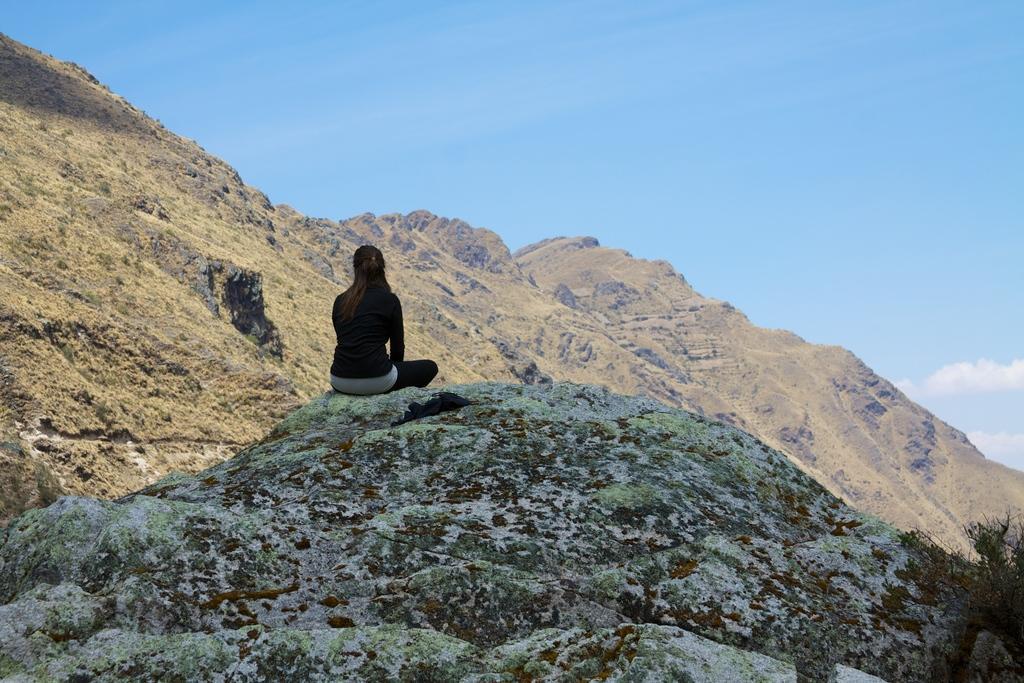How would you summarize this image in a sentence or two? In this picture we can see the beautiful view of the mountains. In the center there is a woman wearing a black t-shirt is sitting on the hill. Behind there is a huge mountain. On the top there is a sky. 